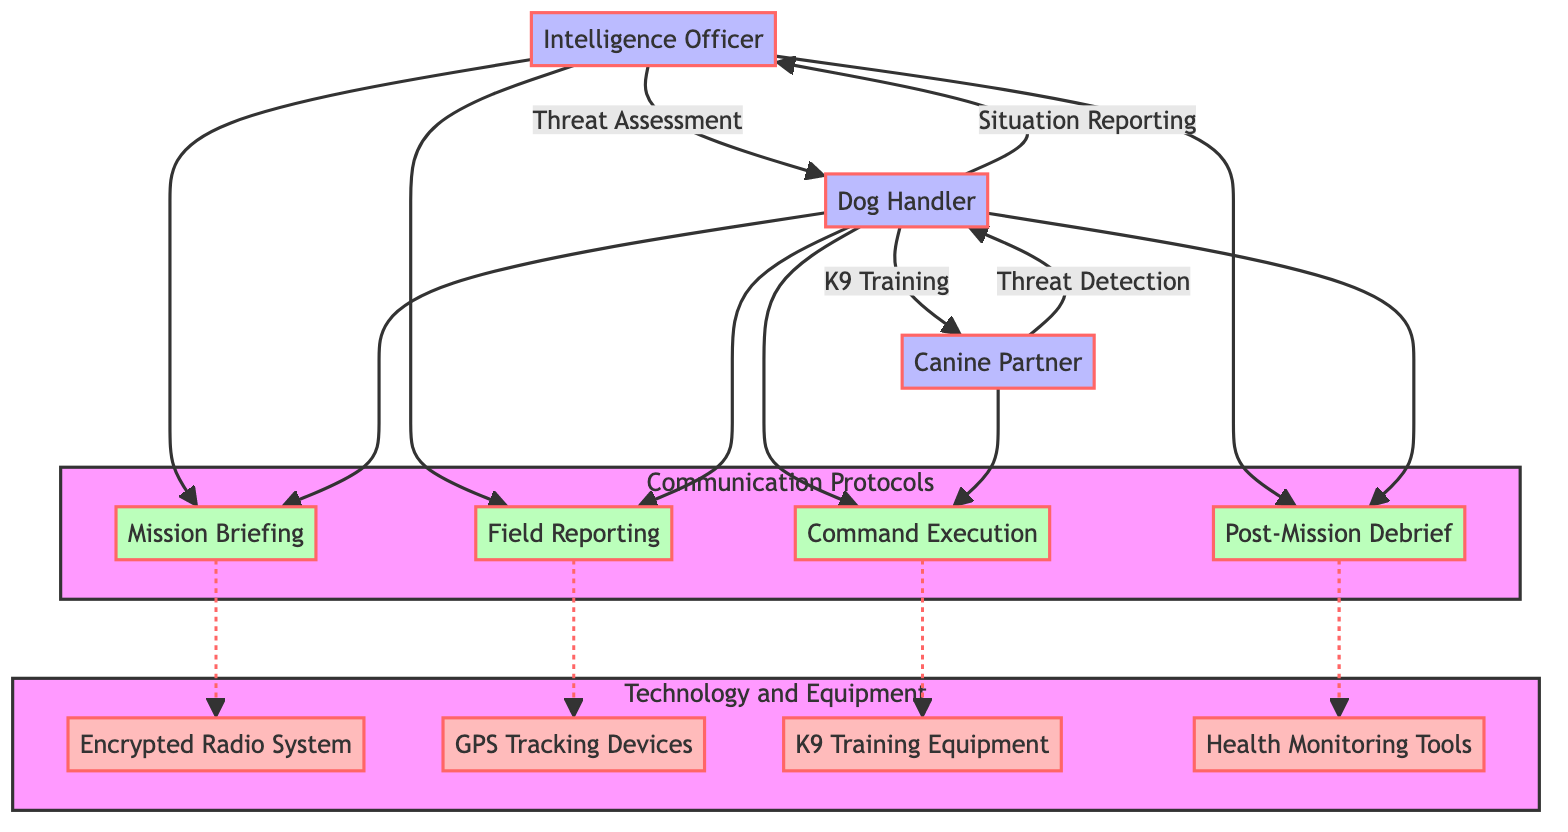What is the primary communication method used in the Mission Briefing? The Mission Briefing uses Encrypted Radio as its communication method, which is explicitly indicated in the diagram.
Answer: Encrypted Radio How many protocols are shown in the Communication Protocols section? There are four protocols listed in the Communication Protocols section: Mission Briefing, Field Reporting, Command Execution, and Post-Mission Debrief.
Answer: Four Which roles are responsible for Command Execution? Command Execution involves the Dog Handler and the Canine Partner, as shown by the connections in the diagram linking these two roles to the Command Execution protocol.
Answer: Dog Handler, Canine Partner What content is covered in the Post-Mission Debrief? The Post-Mission Debrief covers the Mission outcome, lessons learned, and future recommendations, as stated in the diagram information related to this protocol.
Answer: Mission outcome, lessons learned, and future recommendations Which technology is associated with Field Reporting? The technology associated with Field Reporting is GPS Tracking Devices, indicated in the diagram as a component connected to the Field Reporting protocol.
Answer: GPS Tracking Devices How does the Dog Handler communicate Situation Reporting to the Intelligence Officer? Situation Reporting is communicated from the Dog Handler to the Intelligence Officer via Secure Messaging, as shown in the diagram with an arrow labeled accordingly.
Answer: Secure Messaging What type of cues does the Canine Partner use for communication? The Canine Partner communicates using Hand Signals, Verbal Commands, and Behavioral Cues, which are listed under the communication methods of the canine.
Answer: Hand Signals, Verbal Commands, Behavioral Cues How many nodes are there in the Technology and Equipment section? The Technology and Equipment section contains four nodes: Encrypted Radio System, GPS Tracking Devices, K9 Training Equipment, and Health Monitoring Tools.
Answer: Four What is the method of communication used in the Command Execution protocol? The method of communication used in Command Execution is Hand Signals and Verbal Commands, which is specified in the corresponding part of the diagram.
Answer: Hand Signals, Verbal Commands 